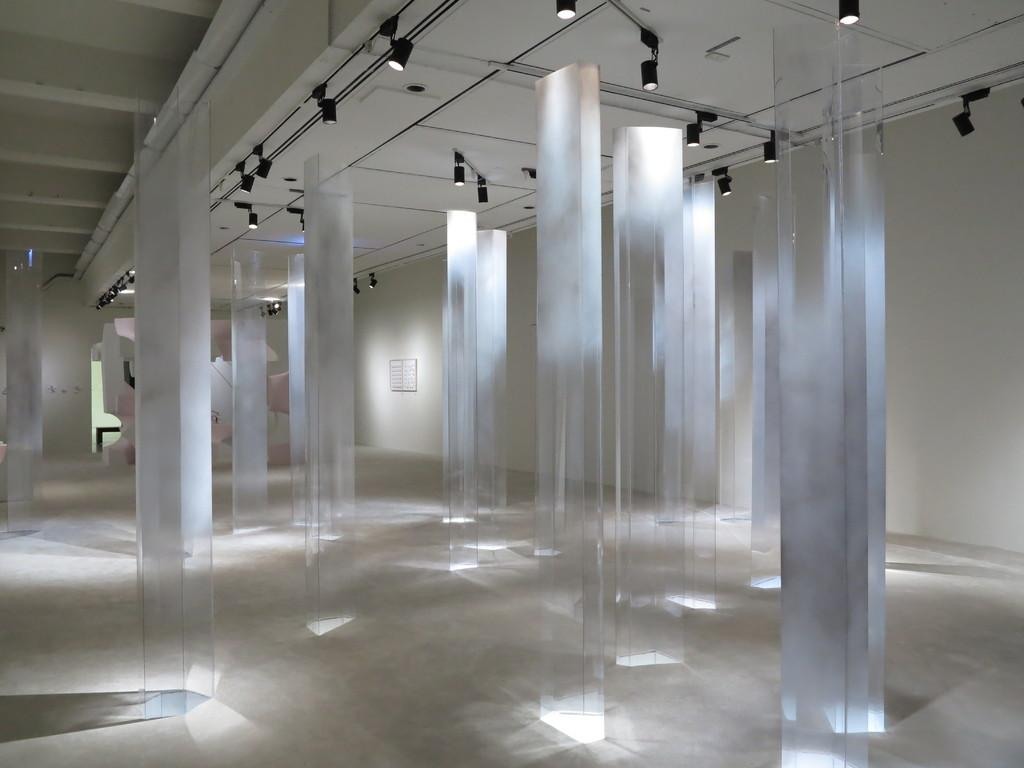Where was the image taken? The image was taken in a hall. What type of architectural feature can be seen in the hall? There are glass pillars in the hall. What is the primary structural element in the hall? There is a wall in the hall. What is the source of light in the hall? There are lights on the ceiling. What can be seen in the background of the image? There are objects in the background of the image. What type of cherries are growing on the ground in the image? There are no cherries or ground present in the image; it is taken in a hall with glass pillars, a wall, lights on the ceiling, and objects in the background. 